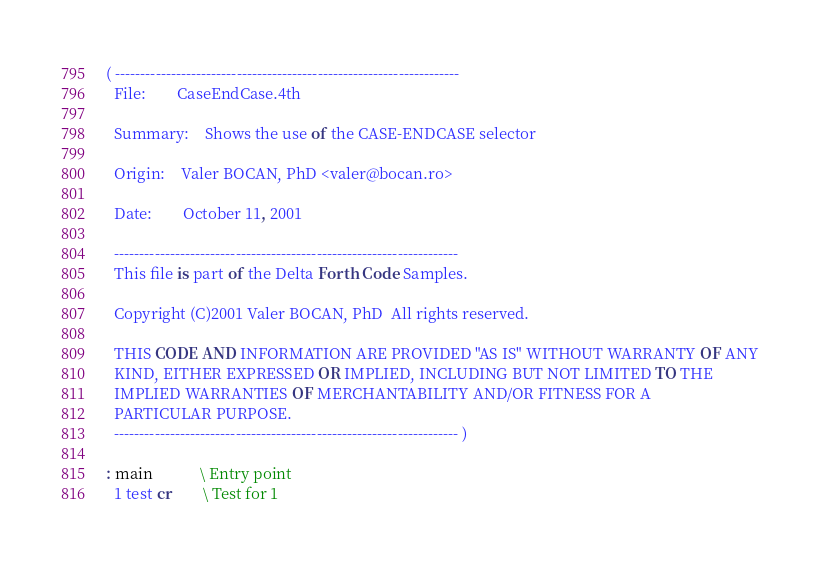Convert code to text. <code><loc_0><loc_0><loc_500><loc_500><_Forth_>( --------------------------------------------------------------------
  File:		CaseEndCase.4th

  Summary:	Shows the use of the CASE-ENDCASE selector

  Origin:	Valer BOCAN, PhD <valer@bocan.ro>

  Date:		October 11, 2001

  --------------------------------------------------------------------
  This file is part of the Delta Forth Code Samples.

  Copyright (C)2001 Valer BOCAN, PhD  All rights reserved.

  THIS CODE AND INFORMATION ARE PROVIDED "AS IS" WITHOUT WARRANTY OF ANY
  KIND, EITHER EXPRESSED OR IMPLIED, INCLUDING BUT NOT LIMITED TO THE
  IMPLIED WARRANTIES OF MERCHANTABILITY AND/OR FITNESS FOR A
  PARTICULAR PURPOSE.
  -------------------------------------------------------------------- )

: main			\ Entry point
  1 test cr		\ Test for 1</code> 